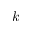Convert formula to latex. <formula><loc_0><loc_0><loc_500><loc_500>k</formula> 